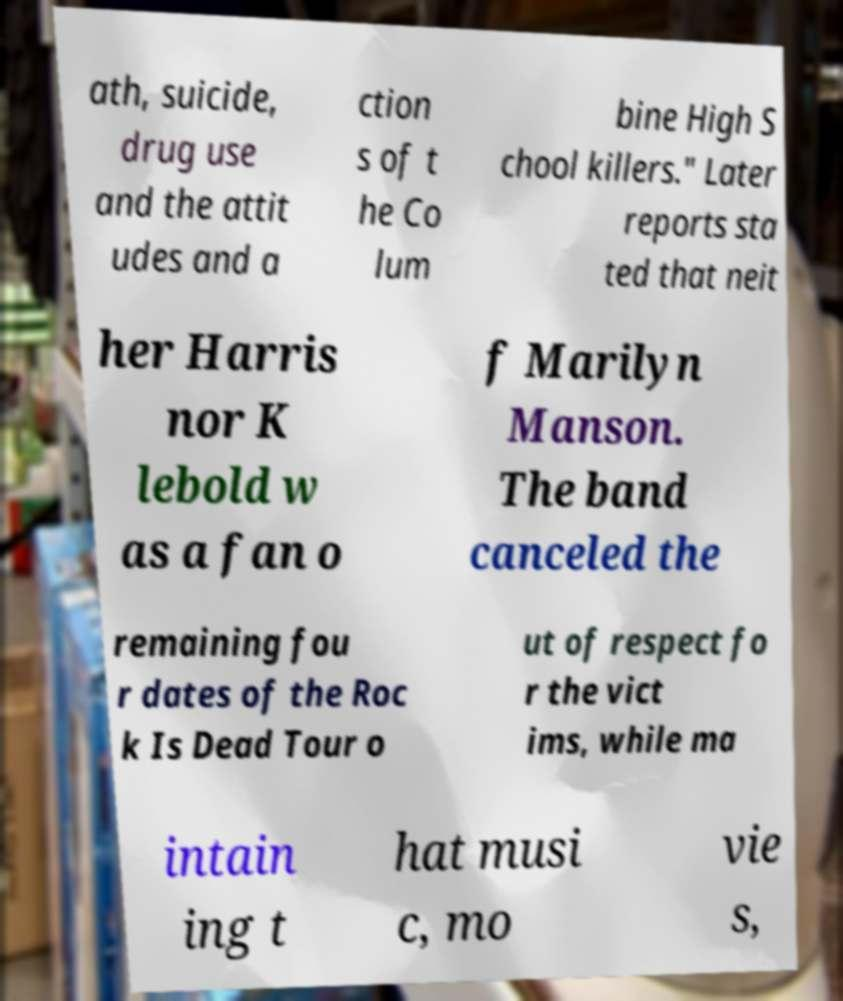Can you accurately transcribe the text from the provided image for me? ath, suicide, drug use and the attit udes and a ction s of t he Co lum bine High S chool killers." Later reports sta ted that neit her Harris nor K lebold w as a fan o f Marilyn Manson. The band canceled the remaining fou r dates of the Roc k Is Dead Tour o ut of respect fo r the vict ims, while ma intain ing t hat musi c, mo vie s, 